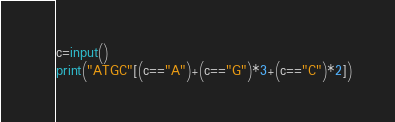Convert code to text. <code><loc_0><loc_0><loc_500><loc_500><_Python_>c=input()
print("ATGC"[(c=="A")+(c=="G")*3+(c=="C")*2])</code> 